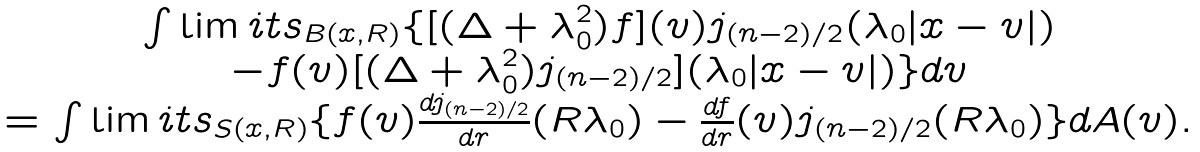<formula> <loc_0><loc_0><loc_500><loc_500>\begin{array} { c } \int \lim i t s _ { B ( x , R ) } \{ [ ( \Delta + \lambda _ { 0 } ^ { 2 } ) f ] ( v ) j _ { ( n - 2 ) / 2 } ( \lambda _ { 0 } | x - v | ) \\ - f ( v ) [ ( \Delta + \lambda _ { 0 } ^ { 2 } ) j _ { ( n - 2 ) / 2 } ] ( \lambda _ { 0 } | x - v | ) \} d v \\ = \int \lim i t s _ { S ( x , R ) } \{ f ( v ) \frac { d j _ { ( n - 2 ) / 2 } } { d r } ( R \lambda _ { 0 } ) - \frac { d f } { d r } ( v ) j _ { ( n - 2 ) / 2 } ( R \lambda _ { 0 } ) \} d A ( v ) . \end{array}</formula> 